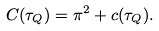Convert formula to latex. <formula><loc_0><loc_0><loc_500><loc_500>C ( \tau _ { Q } ) = \pi ^ { 2 } + c ( \tau _ { Q } ) .</formula> 